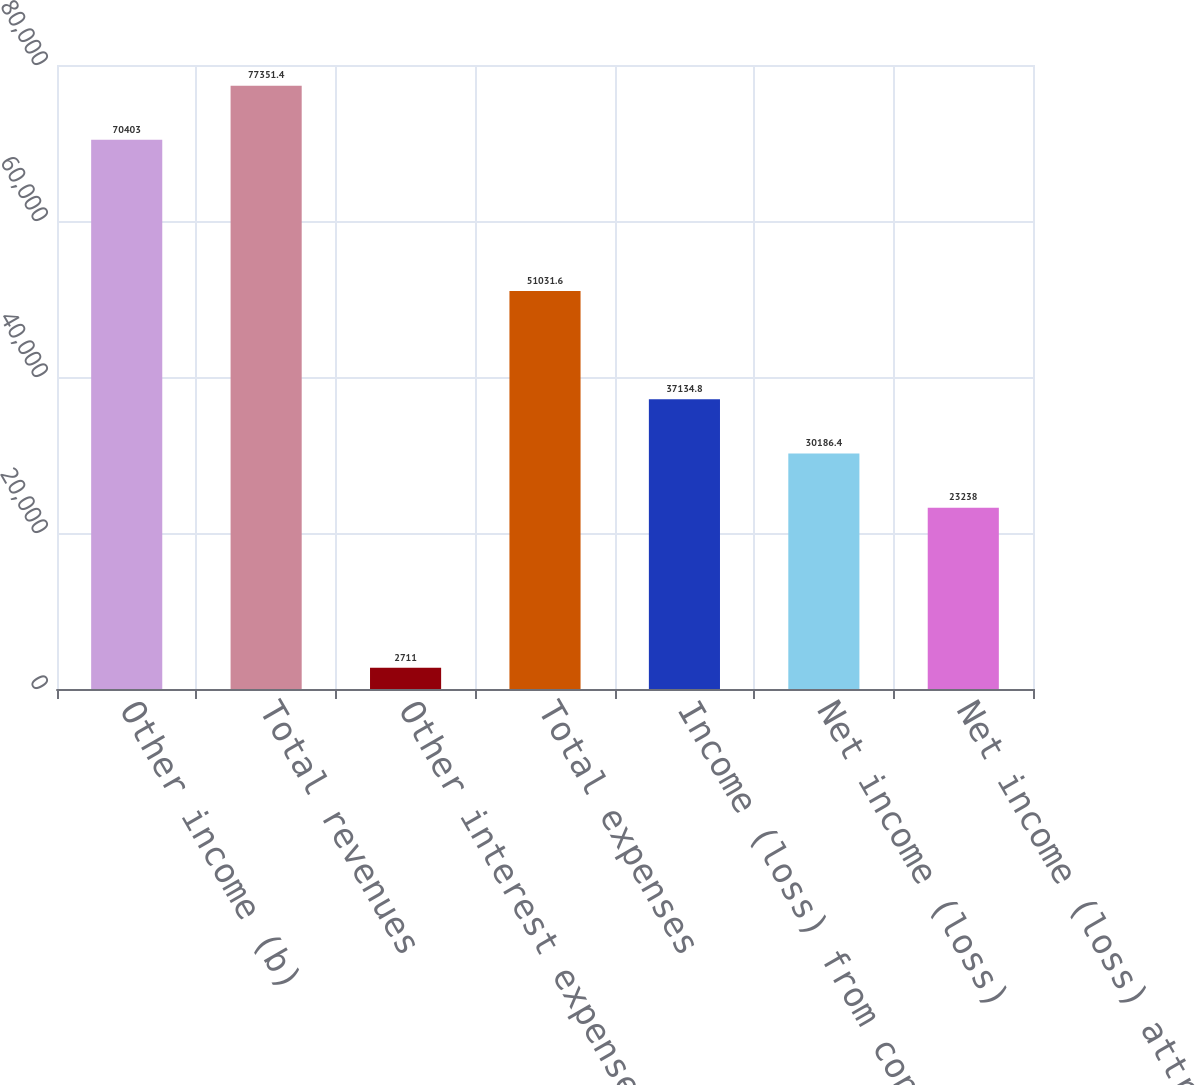Convert chart to OTSL. <chart><loc_0><loc_0><loc_500><loc_500><bar_chart><fcel>Other income (b)<fcel>Total revenues<fcel>Other interest expense (c)<fcel>Total expenses<fcel>Income (loss) from continuing<fcel>Net income (loss)<fcel>Net income (loss) attributable<nl><fcel>70403<fcel>77351.4<fcel>2711<fcel>51031.6<fcel>37134.8<fcel>30186.4<fcel>23238<nl></chart> 